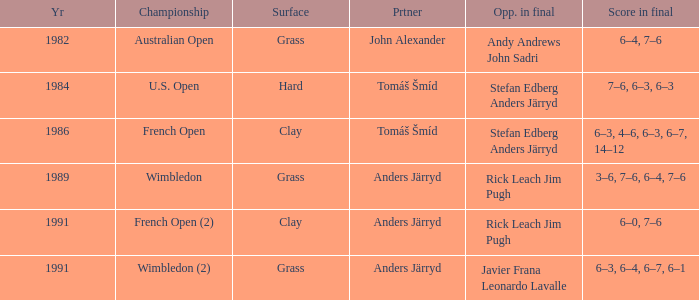Who was his partner in 1989?  Anders Järryd. 